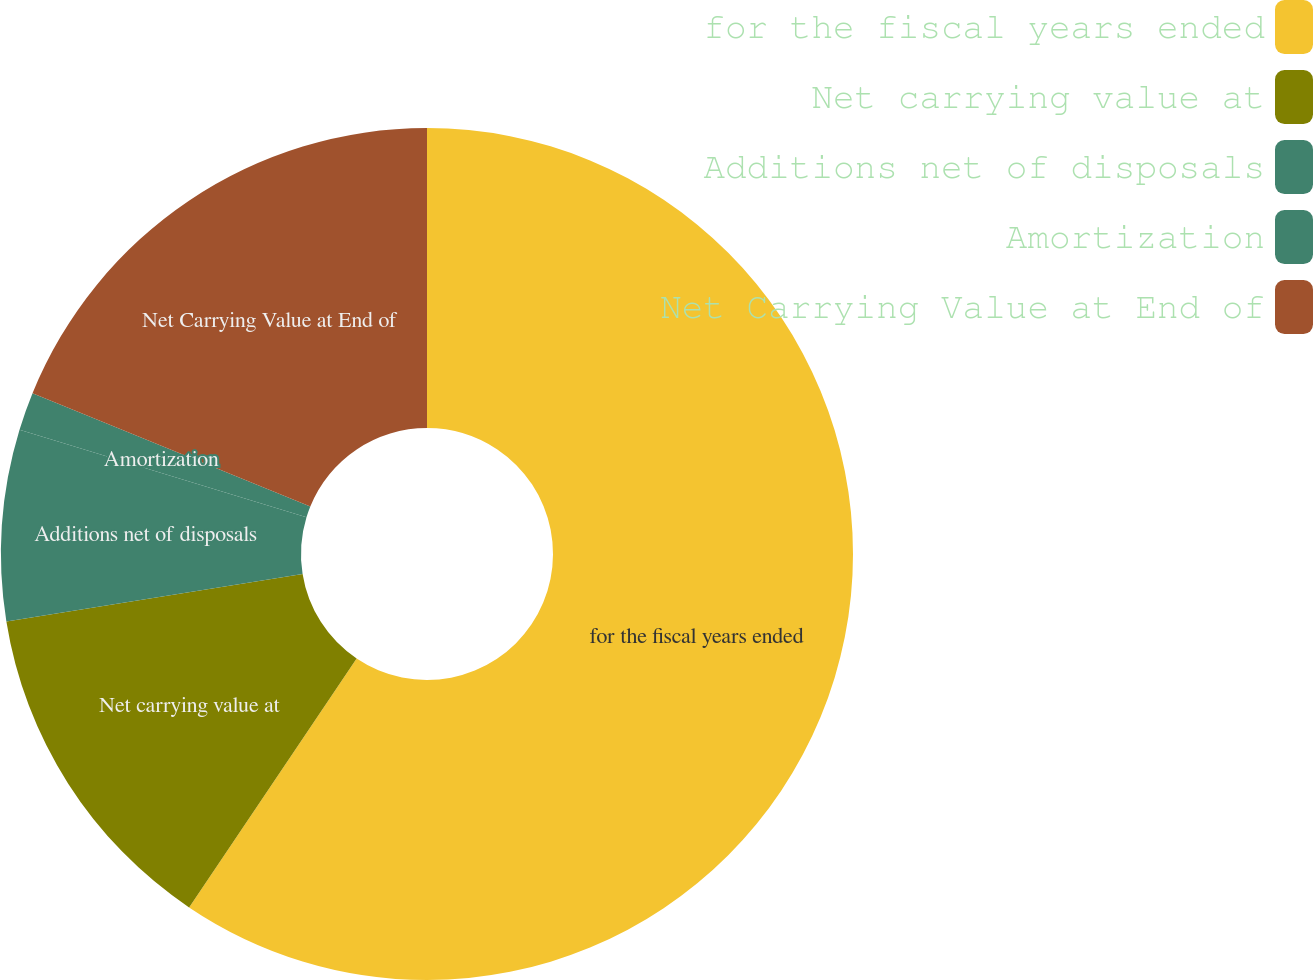Convert chart to OTSL. <chart><loc_0><loc_0><loc_500><loc_500><pie_chart><fcel>for the fiscal years ended<fcel>Net carrying value at<fcel>Additions net of disposals<fcel>Amortization<fcel>Net Carrying Value at End of<nl><fcel>59.43%<fcel>13.04%<fcel>7.24%<fcel>1.45%<fcel>18.84%<nl></chart> 